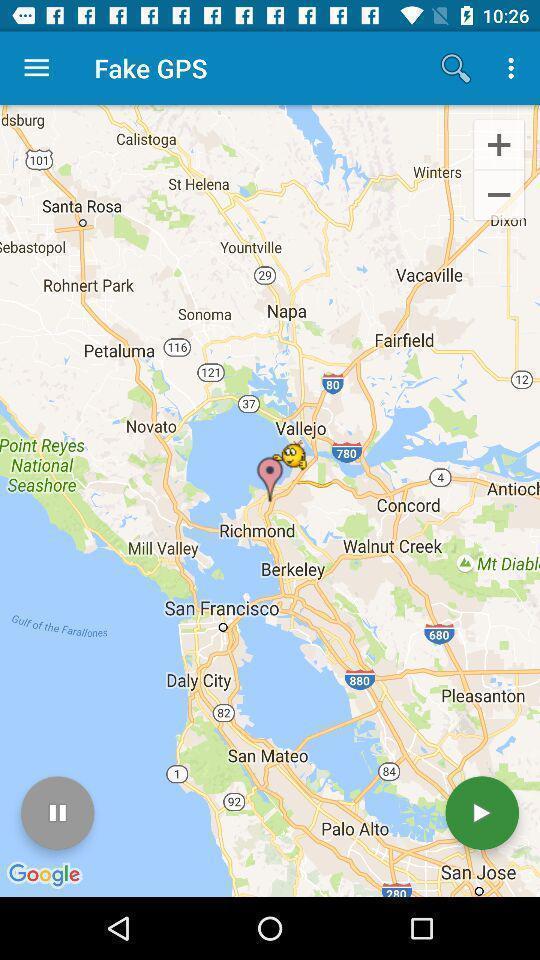Provide a textual representation of this image. Screen displaying fake navigation information. 